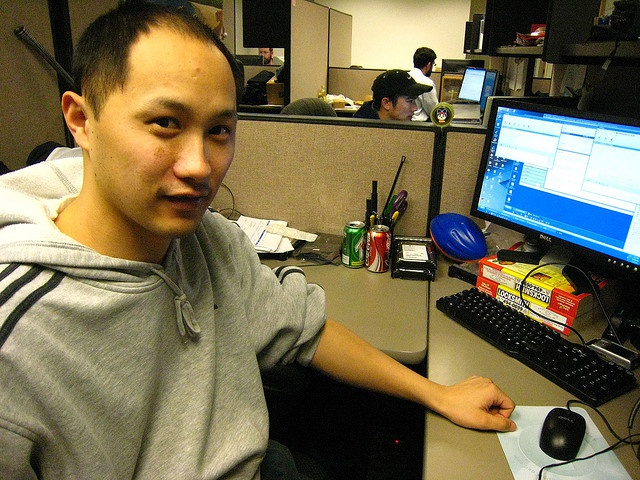Describe the objects in this image and their specific colors. I can see people in maroon, olive, black, and gray tones, tv in maroon, white, blue, black, and lightblue tones, keyboard in maroon, black, gray, and darkgreen tones, book in maroon, black, brown, yellow, and khaki tones, and people in maroon, black, olive, and gray tones in this image. 